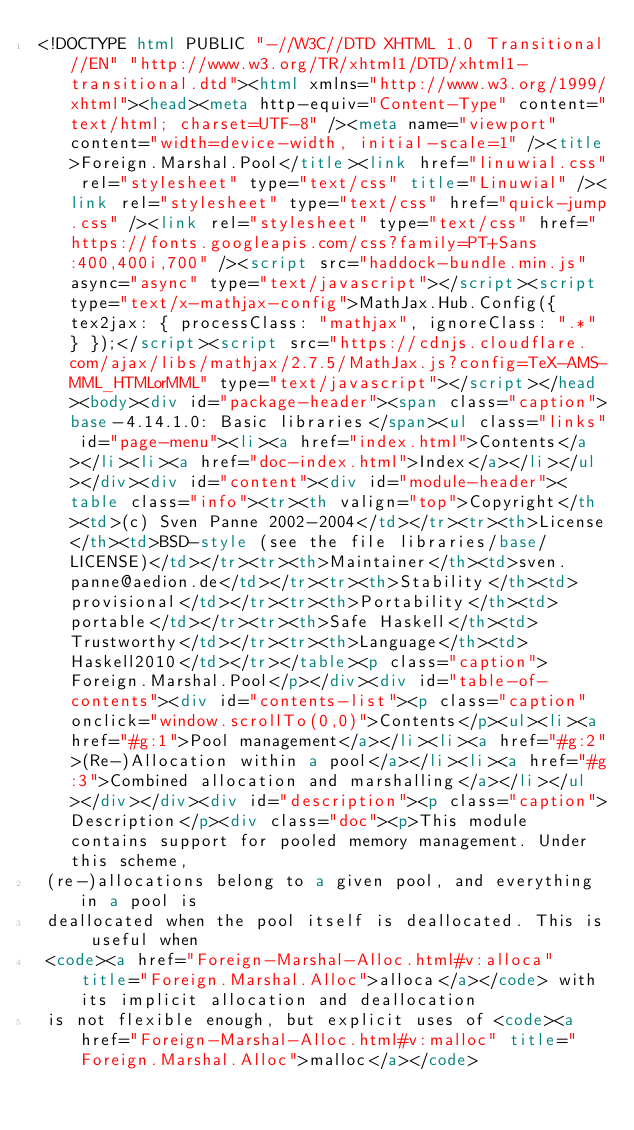<code> <loc_0><loc_0><loc_500><loc_500><_HTML_><!DOCTYPE html PUBLIC "-//W3C//DTD XHTML 1.0 Transitional//EN" "http://www.w3.org/TR/xhtml1/DTD/xhtml1-transitional.dtd"><html xmlns="http://www.w3.org/1999/xhtml"><head><meta http-equiv="Content-Type" content="text/html; charset=UTF-8" /><meta name="viewport" content="width=device-width, initial-scale=1" /><title>Foreign.Marshal.Pool</title><link href="linuwial.css" rel="stylesheet" type="text/css" title="Linuwial" /><link rel="stylesheet" type="text/css" href="quick-jump.css" /><link rel="stylesheet" type="text/css" href="https://fonts.googleapis.com/css?family=PT+Sans:400,400i,700" /><script src="haddock-bundle.min.js" async="async" type="text/javascript"></script><script type="text/x-mathjax-config">MathJax.Hub.Config({ tex2jax: { processClass: "mathjax", ignoreClass: ".*" } });</script><script src="https://cdnjs.cloudflare.com/ajax/libs/mathjax/2.7.5/MathJax.js?config=TeX-AMS-MML_HTMLorMML" type="text/javascript"></script></head><body><div id="package-header"><span class="caption">base-4.14.1.0: Basic libraries</span><ul class="links" id="page-menu"><li><a href="index.html">Contents</a></li><li><a href="doc-index.html">Index</a></li></ul></div><div id="content"><div id="module-header"><table class="info"><tr><th valign="top">Copyright</th><td>(c) Sven Panne 2002-2004</td></tr><tr><th>License</th><td>BSD-style (see the file libraries/base/LICENSE)</td></tr><tr><th>Maintainer</th><td>sven.panne@aedion.de</td></tr><tr><th>Stability</th><td>provisional</td></tr><tr><th>Portability</th><td>portable</td></tr><tr><th>Safe Haskell</th><td>Trustworthy</td></tr><tr><th>Language</th><td>Haskell2010</td></tr></table><p class="caption">Foreign.Marshal.Pool</p></div><div id="table-of-contents"><div id="contents-list"><p class="caption" onclick="window.scrollTo(0,0)">Contents</p><ul><li><a href="#g:1">Pool management</a></li><li><a href="#g:2">(Re-)Allocation within a pool</a></li><li><a href="#g:3">Combined allocation and marshalling</a></li></ul></div></div><div id="description"><p class="caption">Description</p><div class="doc"><p>This module contains support for pooled memory management. Under this scheme,
 (re-)allocations belong to a given pool, and everything in a pool is
 deallocated when the pool itself is deallocated. This is useful when
 <code><a href="Foreign-Marshal-Alloc.html#v:alloca" title="Foreign.Marshal.Alloc">alloca</a></code> with its implicit allocation and deallocation
 is not flexible enough, but explicit uses of <code><a href="Foreign-Marshal-Alloc.html#v:malloc" title="Foreign.Marshal.Alloc">malloc</a></code></code> 